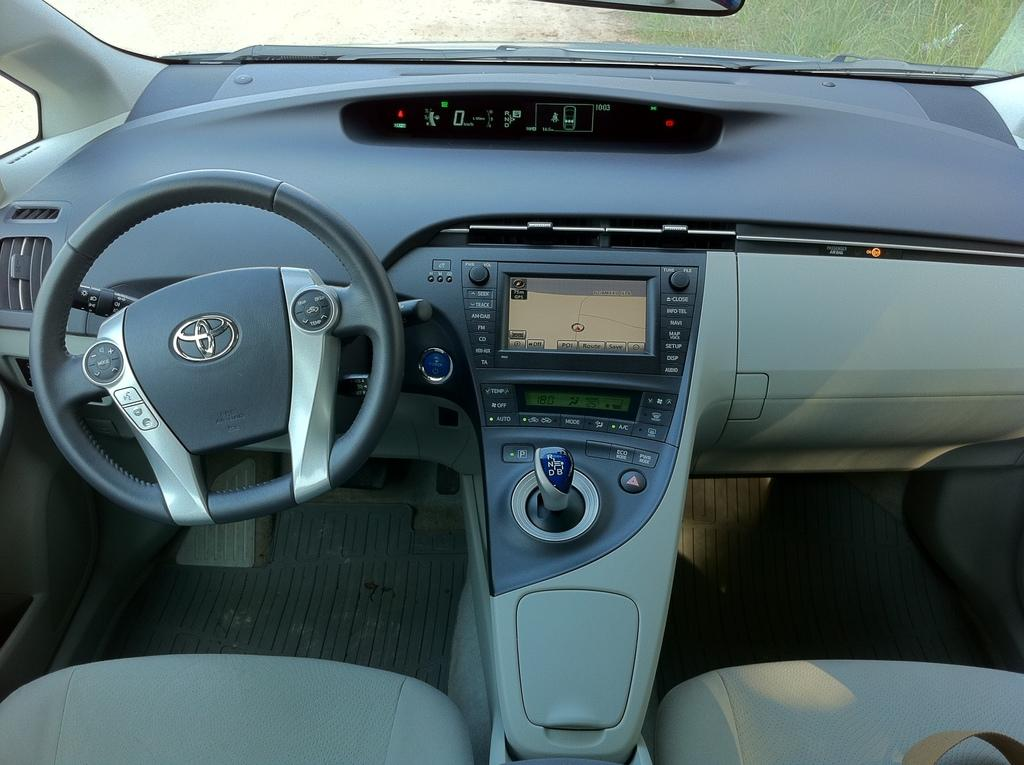What is the setting of the image? The image is of the inside of a car. What is the main control device in the car? There is a steering wheel in the image. What is used to change gears in the car? There is a gear rod in the image. What is used for playing music in the car? There is a music system in the image. What other parts of the car can be seen in the image? There are other parts of the car visible in the image. Can you see the daughter of the car owner in the image? There is no person, let alone a daughter, present in the image; it is a picture of the inside of a car. What type of metal is used to construct the car in the image? The type of metal used to construct the car is not visible or identifiable in the image. 